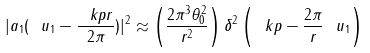Convert formula to latex. <formula><loc_0><loc_0><loc_500><loc_500>| a _ { 1 } ( \ u _ { 1 } - \frac { \ k p r } { 2 \pi } ) | ^ { 2 } \approx \left ( \frac { 2 \pi ^ { 3 } \theta _ { 0 } ^ { 2 } } { r ^ { 2 } } \right ) \delta ^ { 2 } \left ( \ k p - \frac { 2 \pi } { r } \ u _ { 1 } \right )</formula> 